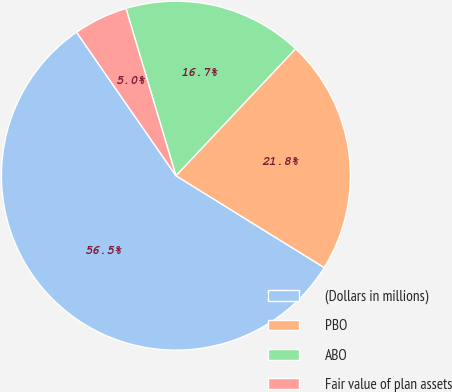Convert chart to OTSL. <chart><loc_0><loc_0><loc_500><loc_500><pie_chart><fcel>(Dollars in millions)<fcel>PBO<fcel>ABO<fcel>Fair value of plan assets<nl><fcel>56.52%<fcel>21.8%<fcel>16.65%<fcel>5.02%<nl></chart> 